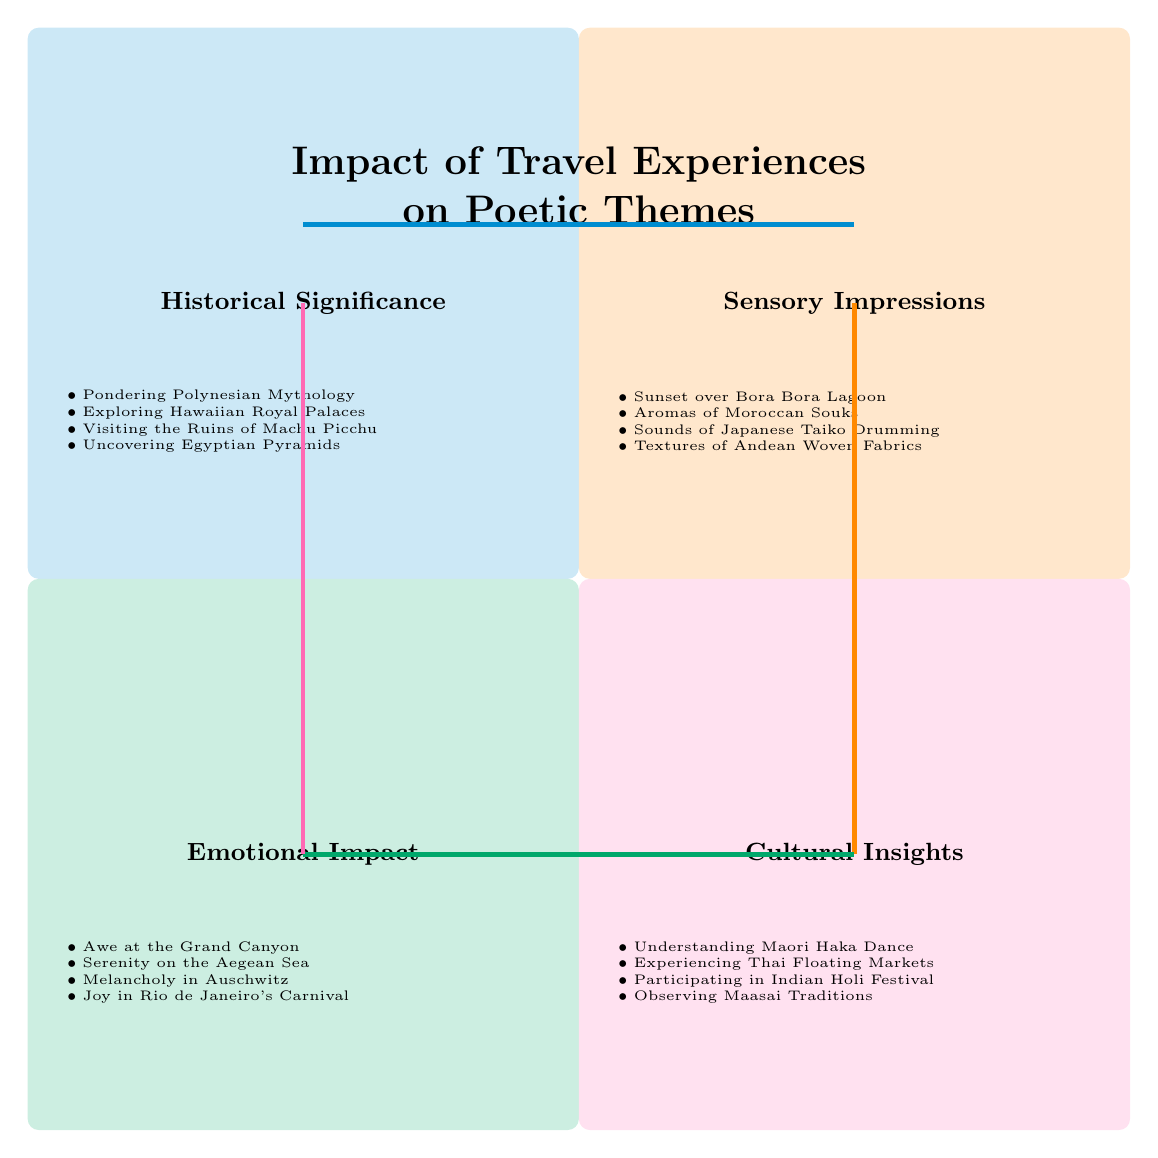What are the elements in the "Historical Significance" quadrant? The "Historical Significance" quadrant lists four elements: "Pondering Polynesian Mythology," "Exploring Hawaiian Royal Palaces," "Visiting the Ruins of Machu Picchu," and "Uncovering Egyptian Pyramids."
Answer: Pondering Polynesian Mythology, Exploring Hawaiian Royal Palaces, Visiting the Ruins of Machu Picchu, Uncovering Egyptian Pyramids How many elements are there in the "Sensory Impressions" quadrant? The "Sensory Impressions" quadrant contains four elements listed within it.
Answer: 4 Which quadrant contains "Melancholy in Auschwitz"? "Melancholy in Auschwitz" is an element found in the "Emotional Impact" quadrant, as evidenced by its placement within that section of the diagram.
Answer: Emotional Impact What is the emotional theme of the "Serenity on the Aegean Sea"? "Serenity on the Aegean Sea" is categorized under the "Emotional Impact" quadrant, which implies a sense of calmness and tranquility linked to travel experiences.
Answer: Calmness Which quadrant has the element "Textures of Andean Woven Fabrics"? The element "Textures of Andean Woven Fabrics" is found in the "Sensory Impressions" quadrant, illustrating the tactile experiences during travel.
Answer: Sensory Impressions How many quadrants are in the diagram? The diagram consists of four quadrants: "Historical Significance," "Sensory Impressions," "Emotional Impact," and "Cultural Insights."
Answer: 4 Which quadrant has the highest emotional theme related to joy? The "Emotional Impact" quadrant features the element "Joy in Rio de Janeiro's Carnival," indicating it is directly associated with the emotional theme of joy.
Answer: Emotional Impact What is the cultural experience described in the "Cultural Insights" quadrant? The "Cultural Insights" quadrant includes experiences such as "Understanding Maori Haka Dance," showcasing the understanding of a cultural performance.
Answer: Understanding Maori Haka Dance What is a sensory experience listed in the diagram related to Morocco? The sensory experience related to Morocco listed in the diagram is "Aromas of Moroccan Souks," representing the fragrant atmosphere of the marketplaces.
Answer: Aromas of Moroccan Souks 